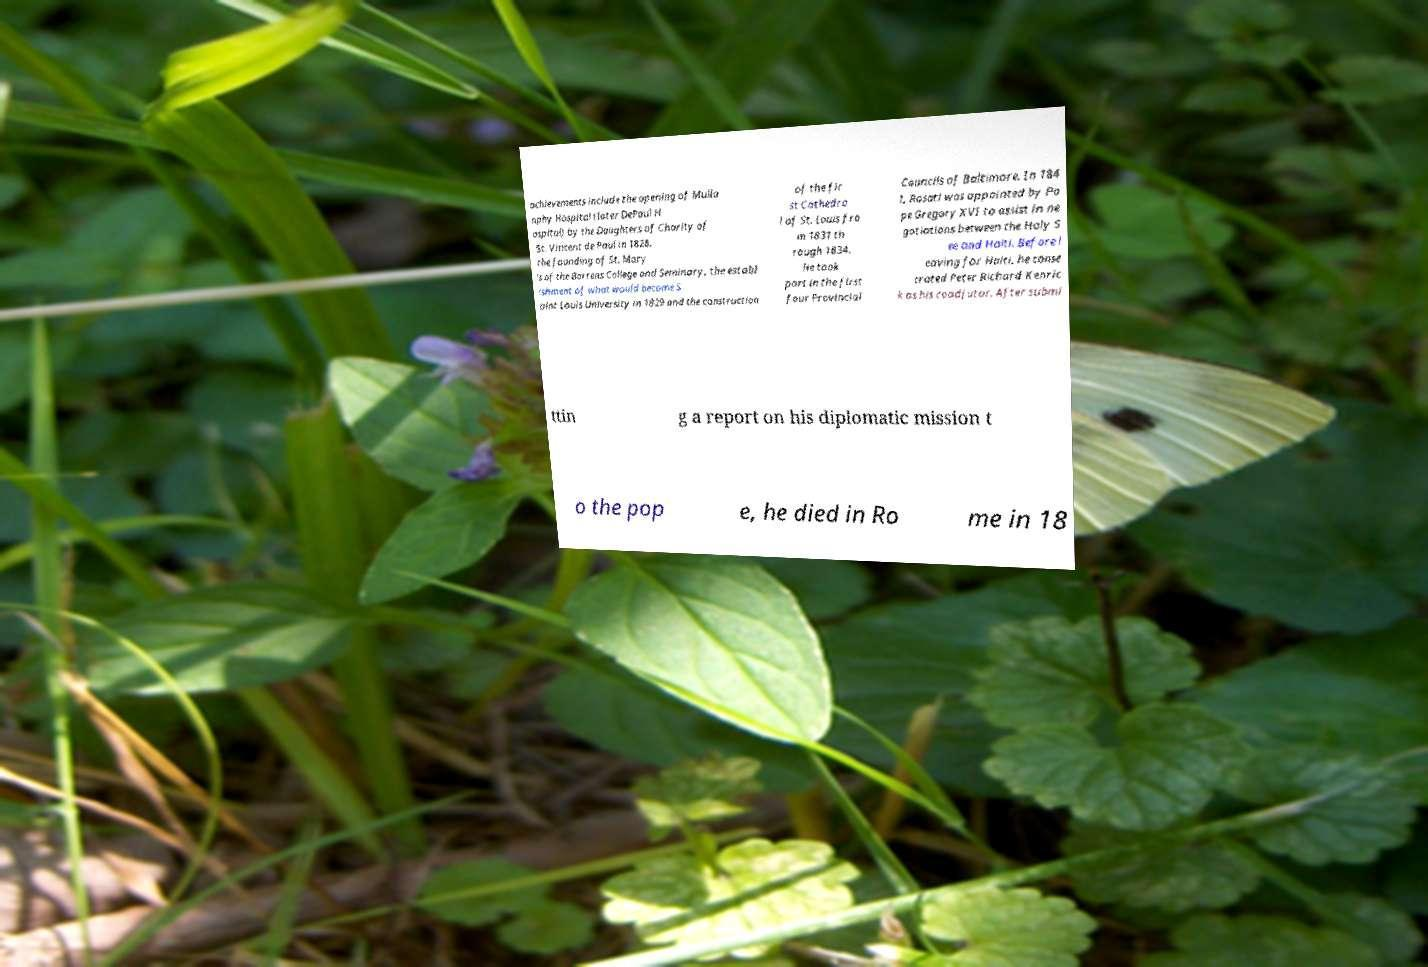There's text embedded in this image that I need extracted. Can you transcribe it verbatim? achievements include the opening of Mulla nphy Hospital (later DePaul H ospital) by the Daughters of Charity of St. Vincent de Paul in 1828, the founding of St. Mary 's of the Barrens College and Seminary, the establ ishment of what would become S aint Louis University in 1829 and the construction of the fir st Cathedra l of St. Louis fro m 1831 th rough 1834. He took part in the first four Provincial Councils of Baltimore. In 184 1, Rosati was appointed by Po pe Gregory XVI to assist in ne gotiations between the Holy S ee and Haiti. Before l eaving for Haiti, he conse crated Peter Richard Kenric k as his coadjutor. After submi ttin g a report on his diplomatic mission t o the pop e, he died in Ro me in 18 